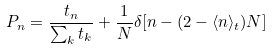<formula> <loc_0><loc_0><loc_500><loc_500>P _ { n } = \frac { t _ { n } } { \sum _ { k } t _ { k } } + \frac { 1 } { N } \delta [ n - ( 2 - \langle n \rangle _ { t } ) N ]</formula> 